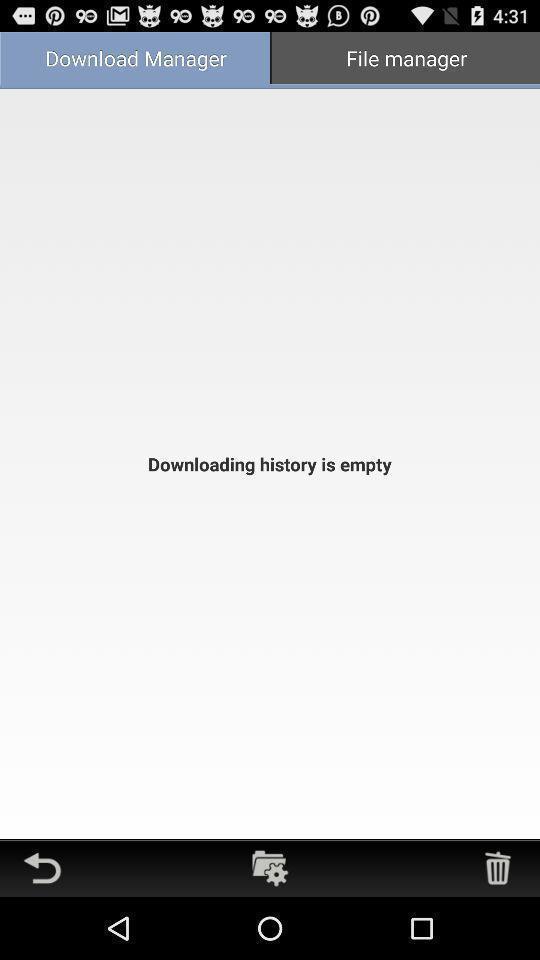Provide a description of this screenshot. Page showing two different manager options. 